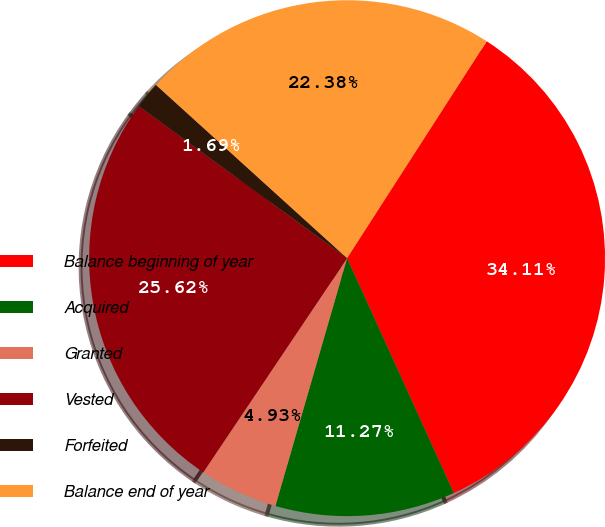<chart> <loc_0><loc_0><loc_500><loc_500><pie_chart><fcel>Balance beginning of year<fcel>Acquired<fcel>Granted<fcel>Vested<fcel>Forfeited<fcel>Balance end of year<nl><fcel>34.11%<fcel>11.27%<fcel>4.93%<fcel>25.62%<fcel>1.69%<fcel>22.38%<nl></chart> 